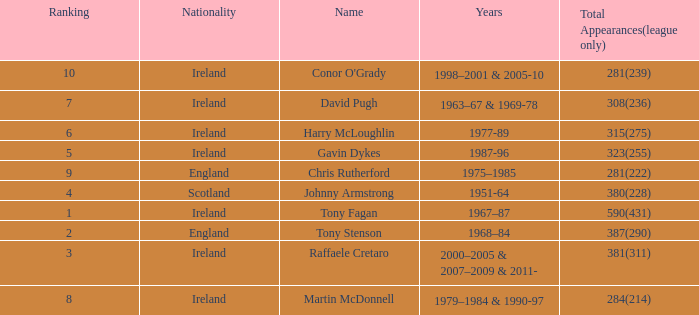How many total appearances (league only) have a name of gavin dykes? 323(255). 